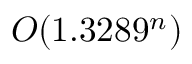<formula> <loc_0><loc_0><loc_500><loc_500>O ( 1 . 3 2 8 9 ^ { n } )</formula> 